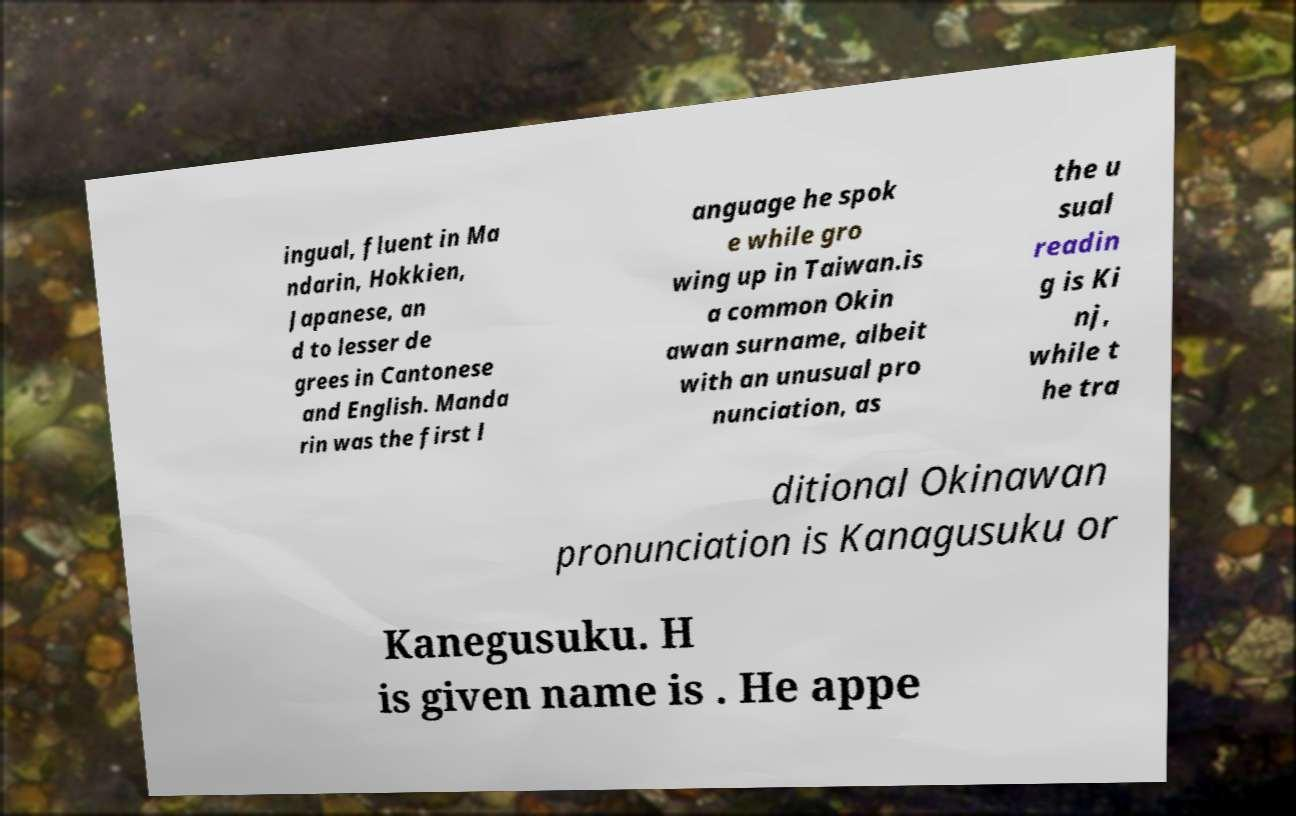What messages or text are displayed in this image? I need them in a readable, typed format. ingual, fluent in Ma ndarin, Hokkien, Japanese, an d to lesser de grees in Cantonese and English. Manda rin was the first l anguage he spok e while gro wing up in Taiwan.is a common Okin awan surname, albeit with an unusual pro nunciation, as the u sual readin g is Ki nj, while t he tra ditional Okinawan pronunciation is Kanagusuku or Kanegusuku. H is given name is . He appe 